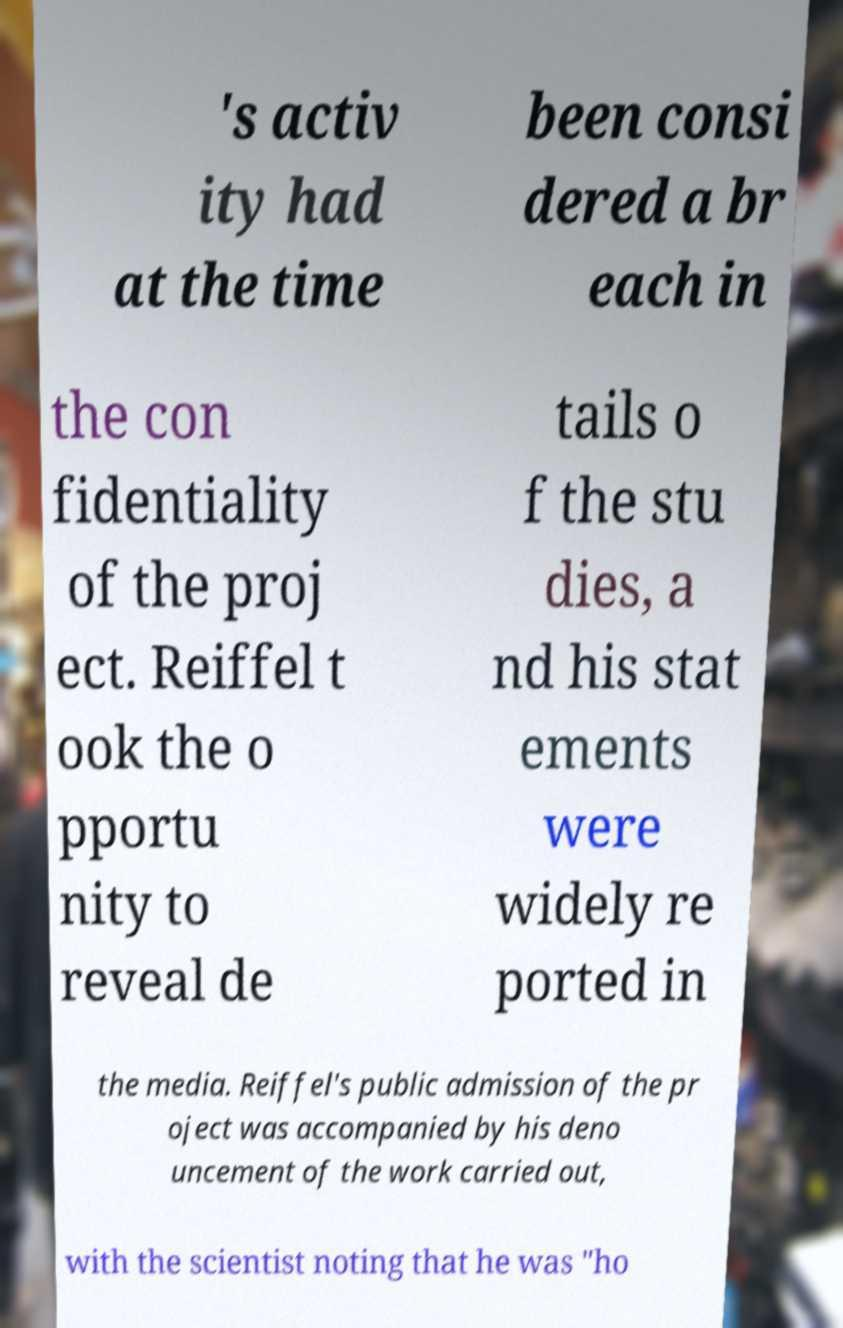What messages or text are displayed in this image? I need them in a readable, typed format. 's activ ity had at the time been consi dered a br each in the con fidentiality of the proj ect. Reiffel t ook the o pportu nity to reveal de tails o f the stu dies, a nd his stat ements were widely re ported in the media. Reiffel's public admission of the pr oject was accompanied by his deno uncement of the work carried out, with the scientist noting that he was "ho 